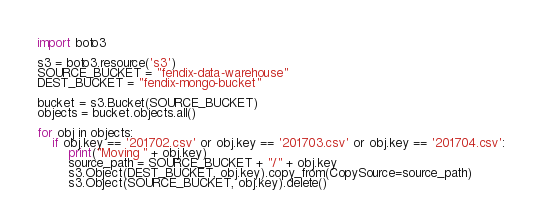Convert code to text. <code><loc_0><loc_0><loc_500><loc_500><_Python_>import boto3

s3 = boto3.resource('s3')
SOURCE_BUCKET = "fendix-data-warehouse"
DEST_BUCKET = "fendix-mongo-bucket"

bucket = s3.Bucket(SOURCE_BUCKET)
objects = bucket.objects.all()

for obj in objects:
    if obj.key == '201702.csv' or obj.key == '201703.csv' or obj.key == '201704.csv':
        print("Moving " + obj.key)
        source_path = SOURCE_BUCKET + "/" + obj.key
        s3.Object(DEST_BUCKET, obj.key).copy_from(CopySource=source_path)
        s3.Object(SOURCE_BUCKET, obj.key).delete()</code> 